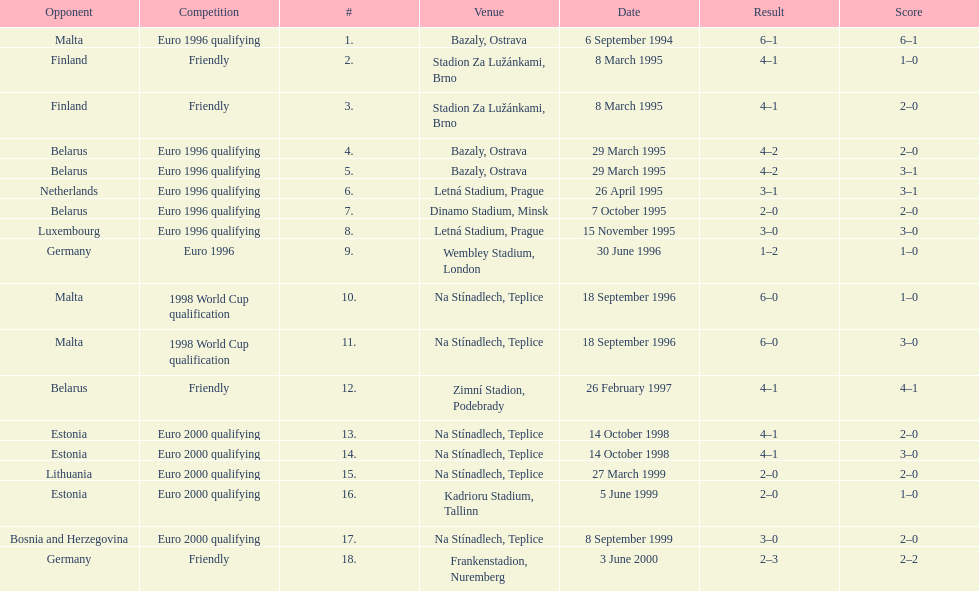Which team did czech republic score the most goals against? Malta. 